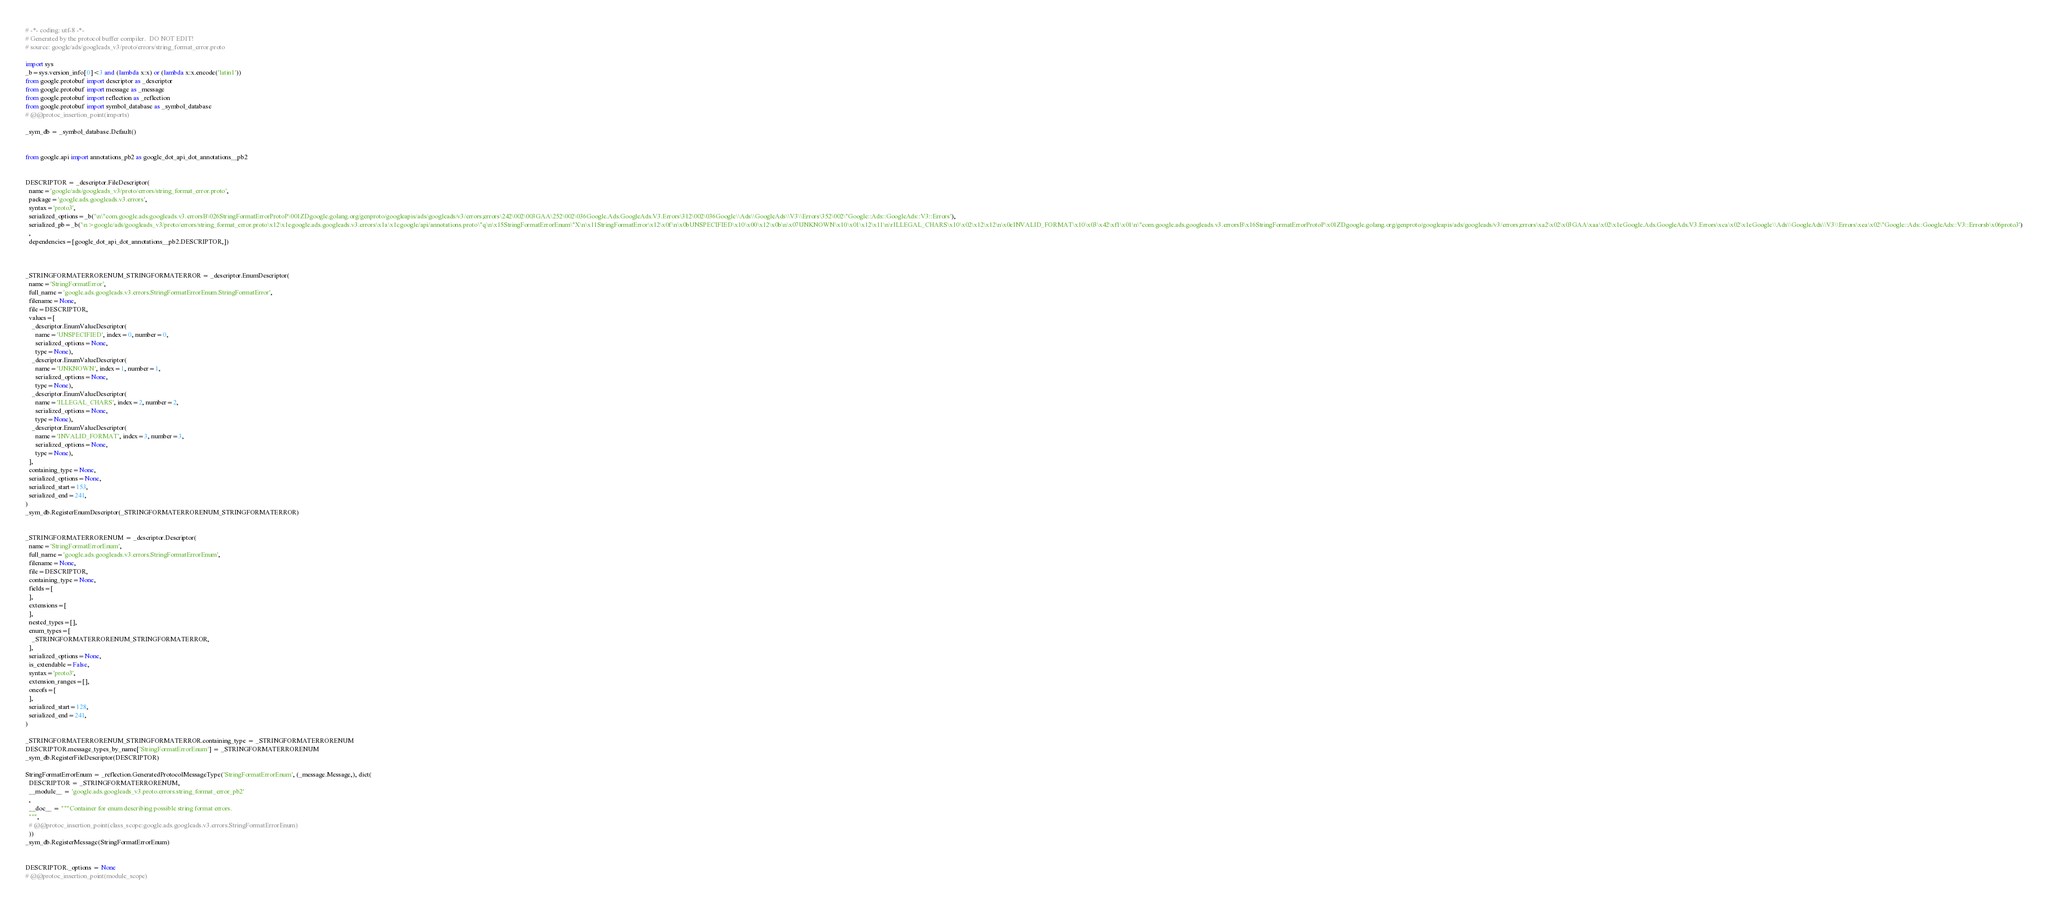<code> <loc_0><loc_0><loc_500><loc_500><_Python_># -*- coding: utf-8 -*-
# Generated by the protocol buffer compiler.  DO NOT EDIT!
# source: google/ads/googleads_v3/proto/errors/string_format_error.proto

import sys
_b=sys.version_info[0]<3 and (lambda x:x) or (lambda x:x.encode('latin1'))
from google.protobuf import descriptor as _descriptor
from google.protobuf import message as _message
from google.protobuf import reflection as _reflection
from google.protobuf import symbol_database as _symbol_database
# @@protoc_insertion_point(imports)

_sym_db = _symbol_database.Default()


from google.api import annotations_pb2 as google_dot_api_dot_annotations__pb2


DESCRIPTOR = _descriptor.FileDescriptor(
  name='google/ads/googleads_v3/proto/errors/string_format_error.proto',
  package='google.ads.googleads.v3.errors',
  syntax='proto3',
  serialized_options=_b('\n\"com.google.ads.googleads.v3.errorsB\026StringFormatErrorProtoP\001ZDgoogle.golang.org/genproto/googleapis/ads/googleads/v3/errors;errors\242\002\003GAA\252\002\036Google.Ads.GoogleAds.V3.Errors\312\002\036Google\\Ads\\GoogleAds\\V3\\Errors\352\002\"Google::Ads::GoogleAds::V3::Errors'),
  serialized_pb=_b('\n>google/ads/googleads_v3/proto/errors/string_format_error.proto\x12\x1egoogle.ads.googleads.v3.errors\x1a\x1cgoogle/api/annotations.proto\"q\n\x15StringFormatErrorEnum\"X\n\x11StringFormatError\x12\x0f\n\x0bUNSPECIFIED\x10\x00\x12\x0b\n\x07UNKNOWN\x10\x01\x12\x11\n\rILLEGAL_CHARS\x10\x02\x12\x12\n\x0eINVALID_FORMAT\x10\x03\x42\xf1\x01\n\"com.google.ads.googleads.v3.errorsB\x16StringFormatErrorProtoP\x01ZDgoogle.golang.org/genproto/googleapis/ads/googleads/v3/errors;errors\xa2\x02\x03GAA\xaa\x02\x1eGoogle.Ads.GoogleAds.V3.Errors\xca\x02\x1eGoogle\\Ads\\GoogleAds\\V3\\Errors\xea\x02\"Google::Ads::GoogleAds::V3::Errorsb\x06proto3')
  ,
  dependencies=[google_dot_api_dot_annotations__pb2.DESCRIPTOR,])



_STRINGFORMATERRORENUM_STRINGFORMATERROR = _descriptor.EnumDescriptor(
  name='StringFormatError',
  full_name='google.ads.googleads.v3.errors.StringFormatErrorEnum.StringFormatError',
  filename=None,
  file=DESCRIPTOR,
  values=[
    _descriptor.EnumValueDescriptor(
      name='UNSPECIFIED', index=0, number=0,
      serialized_options=None,
      type=None),
    _descriptor.EnumValueDescriptor(
      name='UNKNOWN', index=1, number=1,
      serialized_options=None,
      type=None),
    _descriptor.EnumValueDescriptor(
      name='ILLEGAL_CHARS', index=2, number=2,
      serialized_options=None,
      type=None),
    _descriptor.EnumValueDescriptor(
      name='INVALID_FORMAT', index=3, number=3,
      serialized_options=None,
      type=None),
  ],
  containing_type=None,
  serialized_options=None,
  serialized_start=153,
  serialized_end=241,
)
_sym_db.RegisterEnumDescriptor(_STRINGFORMATERRORENUM_STRINGFORMATERROR)


_STRINGFORMATERRORENUM = _descriptor.Descriptor(
  name='StringFormatErrorEnum',
  full_name='google.ads.googleads.v3.errors.StringFormatErrorEnum',
  filename=None,
  file=DESCRIPTOR,
  containing_type=None,
  fields=[
  ],
  extensions=[
  ],
  nested_types=[],
  enum_types=[
    _STRINGFORMATERRORENUM_STRINGFORMATERROR,
  ],
  serialized_options=None,
  is_extendable=False,
  syntax='proto3',
  extension_ranges=[],
  oneofs=[
  ],
  serialized_start=128,
  serialized_end=241,
)

_STRINGFORMATERRORENUM_STRINGFORMATERROR.containing_type = _STRINGFORMATERRORENUM
DESCRIPTOR.message_types_by_name['StringFormatErrorEnum'] = _STRINGFORMATERRORENUM
_sym_db.RegisterFileDescriptor(DESCRIPTOR)

StringFormatErrorEnum = _reflection.GeneratedProtocolMessageType('StringFormatErrorEnum', (_message.Message,), dict(
  DESCRIPTOR = _STRINGFORMATERRORENUM,
  __module__ = 'google.ads.googleads_v3.proto.errors.string_format_error_pb2'
  ,
  __doc__ = """Container for enum describing possible string format errors.
  """,
  # @@protoc_insertion_point(class_scope:google.ads.googleads.v3.errors.StringFormatErrorEnum)
  ))
_sym_db.RegisterMessage(StringFormatErrorEnum)


DESCRIPTOR._options = None
# @@protoc_insertion_point(module_scope)
</code> 